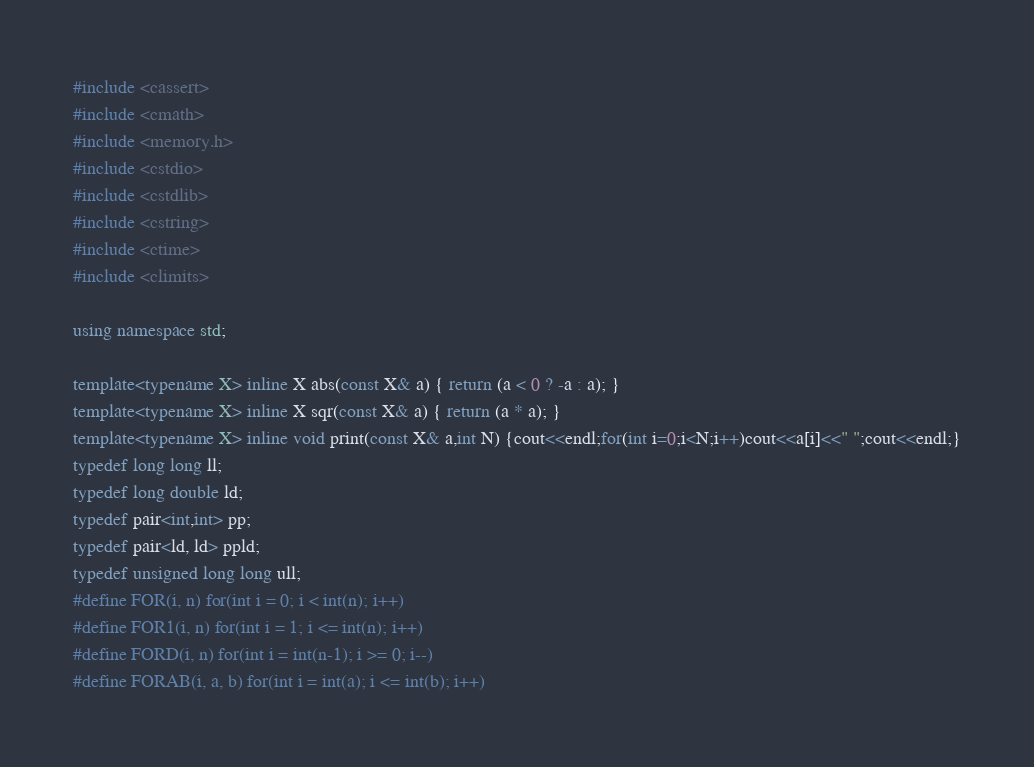<code> <loc_0><loc_0><loc_500><loc_500><_C++_>#include <cassert>
#include <cmath>
#include <memory.h>
#include <cstdio>
#include <cstdlib>
#include <cstring>
#include <ctime>
#include <climits>

using namespace std;

template<typename X> inline X abs(const X& a) { return (a < 0 ? -a : a); }
template<typename X> inline X sqr(const X& a) { return (a * a); }
template<typename X> inline void print(const X& a,int N) {cout<<endl;for(int i=0;i<N;i++)cout<<a[i]<<" ";cout<<endl;}
typedef long long ll;
typedef long double ld;
typedef pair<int,int> pp;
typedef pair<ld, ld> ppld;
typedef unsigned long long ull;
#define FOR(i, n) for(int i = 0; i < int(n); i++)
#define FOR1(i, n) for(int i = 1; i <= int(n); i++)
#define FORD(i, n) for(int i = int(n-1); i >= 0; i--)
#define FORAB(i, a, b) for(int i = int(a); i <= int(b); i++)</code> 